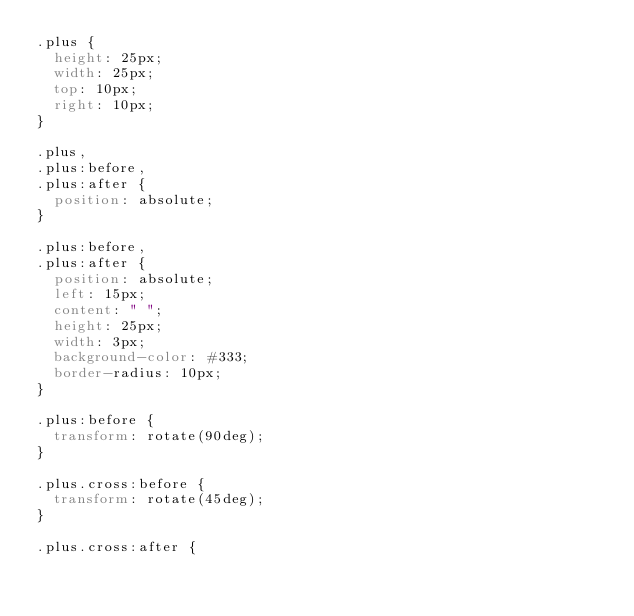<code> <loc_0><loc_0><loc_500><loc_500><_CSS_>.plus {
  height: 25px;
  width: 25px;
  top: 10px;
  right: 10px;
}

.plus,
.plus:before,
.plus:after {
  position: absolute;
}

.plus:before,
.plus:after {
  position: absolute;
  left: 15px;
  content: " ";
  height: 25px;
  width: 3px;
  background-color: #333;
  border-radius: 10px;
}

.plus:before {
  transform: rotate(90deg);
}

.plus.cross:before {
  transform: rotate(45deg);
}

.plus.cross:after {</code> 